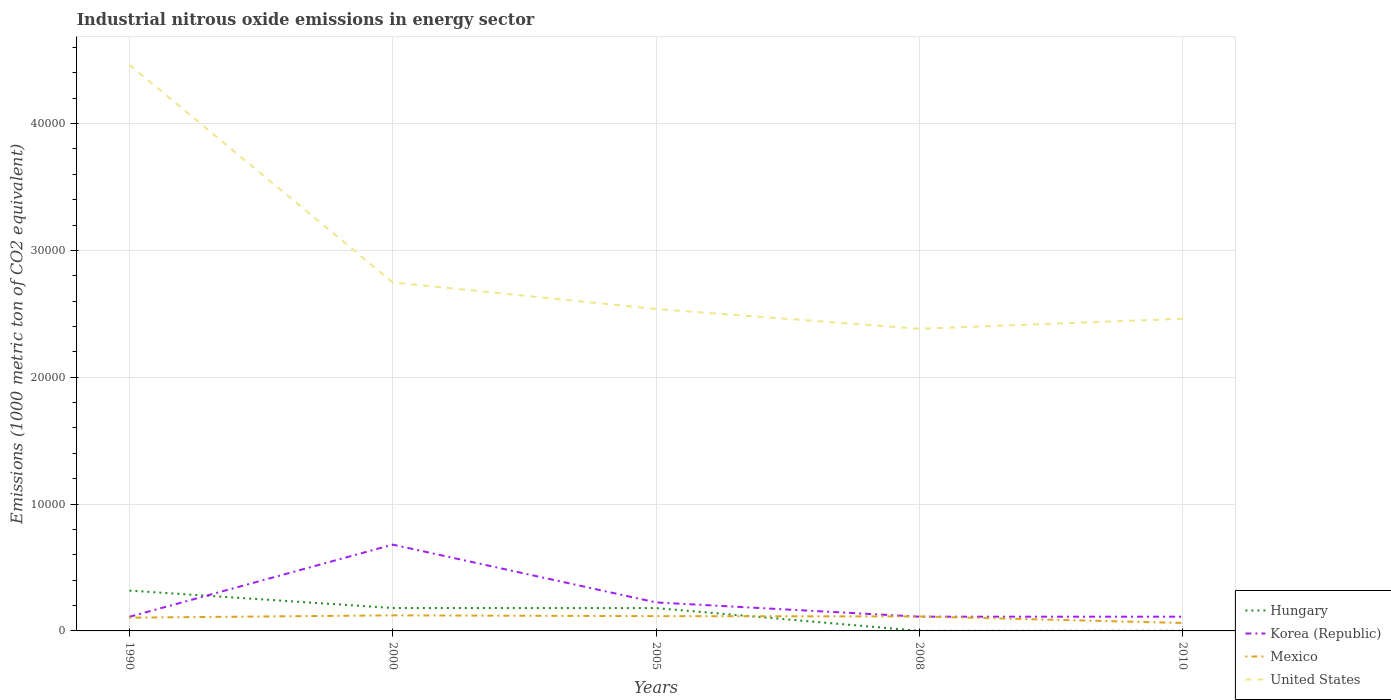Does the line corresponding to Korea (Republic) intersect with the line corresponding to Mexico?
Offer a terse response. Yes. Is the number of lines equal to the number of legend labels?
Make the answer very short. Yes. Across all years, what is the maximum amount of industrial nitrous oxide emitted in United States?
Offer a terse response. 2.38e+04. What is the total amount of industrial nitrous oxide emitted in Hungary in the graph?
Your answer should be very brief. 1376.6. What is the difference between the highest and the second highest amount of industrial nitrous oxide emitted in United States?
Give a very brief answer. 2.08e+04. What is the difference between the highest and the lowest amount of industrial nitrous oxide emitted in Mexico?
Provide a succinct answer. 4. Is the amount of industrial nitrous oxide emitted in Mexico strictly greater than the amount of industrial nitrous oxide emitted in Hungary over the years?
Offer a terse response. No. What is the difference between two consecutive major ticks on the Y-axis?
Keep it short and to the point. 10000. How many legend labels are there?
Offer a very short reply. 4. How are the legend labels stacked?
Offer a terse response. Vertical. What is the title of the graph?
Your response must be concise. Industrial nitrous oxide emissions in energy sector. What is the label or title of the X-axis?
Your answer should be compact. Years. What is the label or title of the Y-axis?
Give a very brief answer. Emissions (1000 metric ton of CO2 equivalent). What is the Emissions (1000 metric ton of CO2 equivalent) of Hungary in 1990?
Your answer should be compact. 3178.6. What is the Emissions (1000 metric ton of CO2 equivalent) in Korea (Republic) in 1990?
Give a very brief answer. 1112.3. What is the Emissions (1000 metric ton of CO2 equivalent) of Mexico in 1990?
Provide a short and direct response. 1046.3. What is the Emissions (1000 metric ton of CO2 equivalent) of United States in 1990?
Give a very brief answer. 4.46e+04. What is the Emissions (1000 metric ton of CO2 equivalent) of Hungary in 2000?
Your answer should be compact. 1805.4. What is the Emissions (1000 metric ton of CO2 equivalent) of Korea (Republic) in 2000?
Give a very brief answer. 6803. What is the Emissions (1000 metric ton of CO2 equivalent) in Mexico in 2000?
Make the answer very short. 1227.6. What is the Emissions (1000 metric ton of CO2 equivalent) of United States in 2000?
Give a very brief answer. 2.75e+04. What is the Emissions (1000 metric ton of CO2 equivalent) of Hungary in 2005?
Your answer should be compact. 1802. What is the Emissions (1000 metric ton of CO2 equivalent) of Korea (Republic) in 2005?
Your answer should be compact. 2247.5. What is the Emissions (1000 metric ton of CO2 equivalent) in Mexico in 2005?
Provide a succinct answer. 1164.8. What is the Emissions (1000 metric ton of CO2 equivalent) in United States in 2005?
Keep it short and to the point. 2.54e+04. What is the Emissions (1000 metric ton of CO2 equivalent) of Korea (Republic) in 2008?
Offer a very short reply. 1121.9. What is the Emissions (1000 metric ton of CO2 equivalent) of Mexico in 2008?
Give a very brief answer. 1141.1. What is the Emissions (1000 metric ton of CO2 equivalent) of United States in 2008?
Keep it short and to the point. 2.38e+04. What is the Emissions (1000 metric ton of CO2 equivalent) in Hungary in 2010?
Ensure brevity in your answer.  12.5. What is the Emissions (1000 metric ton of CO2 equivalent) of Korea (Republic) in 2010?
Make the answer very short. 1122.5. What is the Emissions (1000 metric ton of CO2 equivalent) of Mexico in 2010?
Keep it short and to the point. 626.8. What is the Emissions (1000 metric ton of CO2 equivalent) of United States in 2010?
Your answer should be compact. 2.46e+04. Across all years, what is the maximum Emissions (1000 metric ton of CO2 equivalent) in Hungary?
Make the answer very short. 3178.6. Across all years, what is the maximum Emissions (1000 metric ton of CO2 equivalent) of Korea (Republic)?
Provide a succinct answer. 6803. Across all years, what is the maximum Emissions (1000 metric ton of CO2 equivalent) in Mexico?
Your answer should be very brief. 1227.6. Across all years, what is the maximum Emissions (1000 metric ton of CO2 equivalent) of United States?
Your response must be concise. 4.46e+04. Across all years, what is the minimum Emissions (1000 metric ton of CO2 equivalent) of Hungary?
Your answer should be very brief. 6. Across all years, what is the minimum Emissions (1000 metric ton of CO2 equivalent) of Korea (Republic)?
Offer a very short reply. 1112.3. Across all years, what is the minimum Emissions (1000 metric ton of CO2 equivalent) in Mexico?
Ensure brevity in your answer.  626.8. Across all years, what is the minimum Emissions (1000 metric ton of CO2 equivalent) in United States?
Ensure brevity in your answer.  2.38e+04. What is the total Emissions (1000 metric ton of CO2 equivalent) of Hungary in the graph?
Give a very brief answer. 6804.5. What is the total Emissions (1000 metric ton of CO2 equivalent) of Korea (Republic) in the graph?
Provide a succinct answer. 1.24e+04. What is the total Emissions (1000 metric ton of CO2 equivalent) in Mexico in the graph?
Your response must be concise. 5206.6. What is the total Emissions (1000 metric ton of CO2 equivalent) of United States in the graph?
Make the answer very short. 1.46e+05. What is the difference between the Emissions (1000 metric ton of CO2 equivalent) of Hungary in 1990 and that in 2000?
Provide a short and direct response. 1373.2. What is the difference between the Emissions (1000 metric ton of CO2 equivalent) in Korea (Republic) in 1990 and that in 2000?
Provide a short and direct response. -5690.7. What is the difference between the Emissions (1000 metric ton of CO2 equivalent) in Mexico in 1990 and that in 2000?
Make the answer very short. -181.3. What is the difference between the Emissions (1000 metric ton of CO2 equivalent) in United States in 1990 and that in 2000?
Ensure brevity in your answer.  1.71e+04. What is the difference between the Emissions (1000 metric ton of CO2 equivalent) in Hungary in 1990 and that in 2005?
Provide a short and direct response. 1376.6. What is the difference between the Emissions (1000 metric ton of CO2 equivalent) of Korea (Republic) in 1990 and that in 2005?
Make the answer very short. -1135.2. What is the difference between the Emissions (1000 metric ton of CO2 equivalent) in Mexico in 1990 and that in 2005?
Ensure brevity in your answer.  -118.5. What is the difference between the Emissions (1000 metric ton of CO2 equivalent) of United States in 1990 and that in 2005?
Your answer should be very brief. 1.92e+04. What is the difference between the Emissions (1000 metric ton of CO2 equivalent) of Hungary in 1990 and that in 2008?
Keep it short and to the point. 3172.6. What is the difference between the Emissions (1000 metric ton of CO2 equivalent) of Korea (Republic) in 1990 and that in 2008?
Offer a very short reply. -9.6. What is the difference between the Emissions (1000 metric ton of CO2 equivalent) of Mexico in 1990 and that in 2008?
Keep it short and to the point. -94.8. What is the difference between the Emissions (1000 metric ton of CO2 equivalent) of United States in 1990 and that in 2008?
Your answer should be compact. 2.08e+04. What is the difference between the Emissions (1000 metric ton of CO2 equivalent) in Hungary in 1990 and that in 2010?
Your response must be concise. 3166.1. What is the difference between the Emissions (1000 metric ton of CO2 equivalent) in Mexico in 1990 and that in 2010?
Offer a very short reply. 419.5. What is the difference between the Emissions (1000 metric ton of CO2 equivalent) in United States in 1990 and that in 2010?
Provide a succinct answer. 2.00e+04. What is the difference between the Emissions (1000 metric ton of CO2 equivalent) in Hungary in 2000 and that in 2005?
Provide a succinct answer. 3.4. What is the difference between the Emissions (1000 metric ton of CO2 equivalent) in Korea (Republic) in 2000 and that in 2005?
Ensure brevity in your answer.  4555.5. What is the difference between the Emissions (1000 metric ton of CO2 equivalent) of Mexico in 2000 and that in 2005?
Ensure brevity in your answer.  62.8. What is the difference between the Emissions (1000 metric ton of CO2 equivalent) in United States in 2000 and that in 2005?
Your response must be concise. 2099.2. What is the difference between the Emissions (1000 metric ton of CO2 equivalent) of Hungary in 2000 and that in 2008?
Your answer should be compact. 1799.4. What is the difference between the Emissions (1000 metric ton of CO2 equivalent) of Korea (Republic) in 2000 and that in 2008?
Give a very brief answer. 5681.1. What is the difference between the Emissions (1000 metric ton of CO2 equivalent) in Mexico in 2000 and that in 2008?
Offer a terse response. 86.5. What is the difference between the Emissions (1000 metric ton of CO2 equivalent) of United States in 2000 and that in 2008?
Give a very brief answer. 3660.1. What is the difference between the Emissions (1000 metric ton of CO2 equivalent) of Hungary in 2000 and that in 2010?
Keep it short and to the point. 1792.9. What is the difference between the Emissions (1000 metric ton of CO2 equivalent) in Korea (Republic) in 2000 and that in 2010?
Your answer should be compact. 5680.5. What is the difference between the Emissions (1000 metric ton of CO2 equivalent) in Mexico in 2000 and that in 2010?
Keep it short and to the point. 600.8. What is the difference between the Emissions (1000 metric ton of CO2 equivalent) in United States in 2000 and that in 2010?
Your answer should be very brief. 2866.4. What is the difference between the Emissions (1000 metric ton of CO2 equivalent) in Hungary in 2005 and that in 2008?
Offer a terse response. 1796. What is the difference between the Emissions (1000 metric ton of CO2 equivalent) in Korea (Republic) in 2005 and that in 2008?
Your response must be concise. 1125.6. What is the difference between the Emissions (1000 metric ton of CO2 equivalent) in Mexico in 2005 and that in 2008?
Offer a very short reply. 23.7. What is the difference between the Emissions (1000 metric ton of CO2 equivalent) of United States in 2005 and that in 2008?
Offer a terse response. 1560.9. What is the difference between the Emissions (1000 metric ton of CO2 equivalent) in Hungary in 2005 and that in 2010?
Make the answer very short. 1789.5. What is the difference between the Emissions (1000 metric ton of CO2 equivalent) in Korea (Republic) in 2005 and that in 2010?
Your answer should be very brief. 1125. What is the difference between the Emissions (1000 metric ton of CO2 equivalent) in Mexico in 2005 and that in 2010?
Your answer should be compact. 538. What is the difference between the Emissions (1000 metric ton of CO2 equivalent) of United States in 2005 and that in 2010?
Ensure brevity in your answer.  767.2. What is the difference between the Emissions (1000 metric ton of CO2 equivalent) in Korea (Republic) in 2008 and that in 2010?
Your response must be concise. -0.6. What is the difference between the Emissions (1000 metric ton of CO2 equivalent) in Mexico in 2008 and that in 2010?
Keep it short and to the point. 514.3. What is the difference between the Emissions (1000 metric ton of CO2 equivalent) of United States in 2008 and that in 2010?
Your answer should be very brief. -793.7. What is the difference between the Emissions (1000 metric ton of CO2 equivalent) of Hungary in 1990 and the Emissions (1000 metric ton of CO2 equivalent) of Korea (Republic) in 2000?
Provide a short and direct response. -3624.4. What is the difference between the Emissions (1000 metric ton of CO2 equivalent) in Hungary in 1990 and the Emissions (1000 metric ton of CO2 equivalent) in Mexico in 2000?
Your answer should be very brief. 1951. What is the difference between the Emissions (1000 metric ton of CO2 equivalent) of Hungary in 1990 and the Emissions (1000 metric ton of CO2 equivalent) of United States in 2000?
Your response must be concise. -2.43e+04. What is the difference between the Emissions (1000 metric ton of CO2 equivalent) of Korea (Republic) in 1990 and the Emissions (1000 metric ton of CO2 equivalent) of Mexico in 2000?
Keep it short and to the point. -115.3. What is the difference between the Emissions (1000 metric ton of CO2 equivalent) of Korea (Republic) in 1990 and the Emissions (1000 metric ton of CO2 equivalent) of United States in 2000?
Provide a succinct answer. -2.64e+04. What is the difference between the Emissions (1000 metric ton of CO2 equivalent) in Mexico in 1990 and the Emissions (1000 metric ton of CO2 equivalent) in United States in 2000?
Make the answer very short. -2.64e+04. What is the difference between the Emissions (1000 metric ton of CO2 equivalent) in Hungary in 1990 and the Emissions (1000 metric ton of CO2 equivalent) in Korea (Republic) in 2005?
Give a very brief answer. 931.1. What is the difference between the Emissions (1000 metric ton of CO2 equivalent) of Hungary in 1990 and the Emissions (1000 metric ton of CO2 equivalent) of Mexico in 2005?
Provide a succinct answer. 2013.8. What is the difference between the Emissions (1000 metric ton of CO2 equivalent) in Hungary in 1990 and the Emissions (1000 metric ton of CO2 equivalent) in United States in 2005?
Your response must be concise. -2.22e+04. What is the difference between the Emissions (1000 metric ton of CO2 equivalent) in Korea (Republic) in 1990 and the Emissions (1000 metric ton of CO2 equivalent) in Mexico in 2005?
Offer a terse response. -52.5. What is the difference between the Emissions (1000 metric ton of CO2 equivalent) of Korea (Republic) in 1990 and the Emissions (1000 metric ton of CO2 equivalent) of United States in 2005?
Your response must be concise. -2.43e+04. What is the difference between the Emissions (1000 metric ton of CO2 equivalent) of Mexico in 1990 and the Emissions (1000 metric ton of CO2 equivalent) of United States in 2005?
Provide a succinct answer. -2.43e+04. What is the difference between the Emissions (1000 metric ton of CO2 equivalent) of Hungary in 1990 and the Emissions (1000 metric ton of CO2 equivalent) of Korea (Republic) in 2008?
Offer a very short reply. 2056.7. What is the difference between the Emissions (1000 metric ton of CO2 equivalent) in Hungary in 1990 and the Emissions (1000 metric ton of CO2 equivalent) in Mexico in 2008?
Offer a terse response. 2037.5. What is the difference between the Emissions (1000 metric ton of CO2 equivalent) in Hungary in 1990 and the Emissions (1000 metric ton of CO2 equivalent) in United States in 2008?
Offer a very short reply. -2.06e+04. What is the difference between the Emissions (1000 metric ton of CO2 equivalent) of Korea (Republic) in 1990 and the Emissions (1000 metric ton of CO2 equivalent) of Mexico in 2008?
Provide a succinct answer. -28.8. What is the difference between the Emissions (1000 metric ton of CO2 equivalent) of Korea (Republic) in 1990 and the Emissions (1000 metric ton of CO2 equivalent) of United States in 2008?
Ensure brevity in your answer.  -2.27e+04. What is the difference between the Emissions (1000 metric ton of CO2 equivalent) of Mexico in 1990 and the Emissions (1000 metric ton of CO2 equivalent) of United States in 2008?
Your response must be concise. -2.28e+04. What is the difference between the Emissions (1000 metric ton of CO2 equivalent) of Hungary in 1990 and the Emissions (1000 metric ton of CO2 equivalent) of Korea (Republic) in 2010?
Your answer should be very brief. 2056.1. What is the difference between the Emissions (1000 metric ton of CO2 equivalent) in Hungary in 1990 and the Emissions (1000 metric ton of CO2 equivalent) in Mexico in 2010?
Your response must be concise. 2551.8. What is the difference between the Emissions (1000 metric ton of CO2 equivalent) in Hungary in 1990 and the Emissions (1000 metric ton of CO2 equivalent) in United States in 2010?
Offer a very short reply. -2.14e+04. What is the difference between the Emissions (1000 metric ton of CO2 equivalent) of Korea (Republic) in 1990 and the Emissions (1000 metric ton of CO2 equivalent) of Mexico in 2010?
Your response must be concise. 485.5. What is the difference between the Emissions (1000 metric ton of CO2 equivalent) in Korea (Republic) in 1990 and the Emissions (1000 metric ton of CO2 equivalent) in United States in 2010?
Ensure brevity in your answer.  -2.35e+04. What is the difference between the Emissions (1000 metric ton of CO2 equivalent) in Mexico in 1990 and the Emissions (1000 metric ton of CO2 equivalent) in United States in 2010?
Provide a short and direct response. -2.36e+04. What is the difference between the Emissions (1000 metric ton of CO2 equivalent) in Hungary in 2000 and the Emissions (1000 metric ton of CO2 equivalent) in Korea (Republic) in 2005?
Your answer should be compact. -442.1. What is the difference between the Emissions (1000 metric ton of CO2 equivalent) in Hungary in 2000 and the Emissions (1000 metric ton of CO2 equivalent) in Mexico in 2005?
Make the answer very short. 640.6. What is the difference between the Emissions (1000 metric ton of CO2 equivalent) of Hungary in 2000 and the Emissions (1000 metric ton of CO2 equivalent) of United States in 2005?
Offer a terse response. -2.36e+04. What is the difference between the Emissions (1000 metric ton of CO2 equivalent) in Korea (Republic) in 2000 and the Emissions (1000 metric ton of CO2 equivalent) in Mexico in 2005?
Provide a short and direct response. 5638.2. What is the difference between the Emissions (1000 metric ton of CO2 equivalent) of Korea (Republic) in 2000 and the Emissions (1000 metric ton of CO2 equivalent) of United States in 2005?
Offer a terse response. -1.86e+04. What is the difference between the Emissions (1000 metric ton of CO2 equivalent) of Mexico in 2000 and the Emissions (1000 metric ton of CO2 equivalent) of United States in 2005?
Provide a succinct answer. -2.42e+04. What is the difference between the Emissions (1000 metric ton of CO2 equivalent) in Hungary in 2000 and the Emissions (1000 metric ton of CO2 equivalent) in Korea (Republic) in 2008?
Ensure brevity in your answer.  683.5. What is the difference between the Emissions (1000 metric ton of CO2 equivalent) of Hungary in 2000 and the Emissions (1000 metric ton of CO2 equivalent) of Mexico in 2008?
Provide a succinct answer. 664.3. What is the difference between the Emissions (1000 metric ton of CO2 equivalent) of Hungary in 2000 and the Emissions (1000 metric ton of CO2 equivalent) of United States in 2008?
Your answer should be compact. -2.20e+04. What is the difference between the Emissions (1000 metric ton of CO2 equivalent) of Korea (Republic) in 2000 and the Emissions (1000 metric ton of CO2 equivalent) of Mexico in 2008?
Offer a very short reply. 5661.9. What is the difference between the Emissions (1000 metric ton of CO2 equivalent) of Korea (Republic) in 2000 and the Emissions (1000 metric ton of CO2 equivalent) of United States in 2008?
Make the answer very short. -1.70e+04. What is the difference between the Emissions (1000 metric ton of CO2 equivalent) in Mexico in 2000 and the Emissions (1000 metric ton of CO2 equivalent) in United States in 2008?
Provide a short and direct response. -2.26e+04. What is the difference between the Emissions (1000 metric ton of CO2 equivalent) of Hungary in 2000 and the Emissions (1000 metric ton of CO2 equivalent) of Korea (Republic) in 2010?
Your response must be concise. 682.9. What is the difference between the Emissions (1000 metric ton of CO2 equivalent) in Hungary in 2000 and the Emissions (1000 metric ton of CO2 equivalent) in Mexico in 2010?
Offer a very short reply. 1178.6. What is the difference between the Emissions (1000 metric ton of CO2 equivalent) of Hungary in 2000 and the Emissions (1000 metric ton of CO2 equivalent) of United States in 2010?
Your answer should be very brief. -2.28e+04. What is the difference between the Emissions (1000 metric ton of CO2 equivalent) of Korea (Republic) in 2000 and the Emissions (1000 metric ton of CO2 equivalent) of Mexico in 2010?
Provide a short and direct response. 6176.2. What is the difference between the Emissions (1000 metric ton of CO2 equivalent) in Korea (Republic) in 2000 and the Emissions (1000 metric ton of CO2 equivalent) in United States in 2010?
Provide a short and direct response. -1.78e+04. What is the difference between the Emissions (1000 metric ton of CO2 equivalent) in Mexico in 2000 and the Emissions (1000 metric ton of CO2 equivalent) in United States in 2010?
Your answer should be very brief. -2.34e+04. What is the difference between the Emissions (1000 metric ton of CO2 equivalent) of Hungary in 2005 and the Emissions (1000 metric ton of CO2 equivalent) of Korea (Republic) in 2008?
Your answer should be compact. 680.1. What is the difference between the Emissions (1000 metric ton of CO2 equivalent) of Hungary in 2005 and the Emissions (1000 metric ton of CO2 equivalent) of Mexico in 2008?
Your response must be concise. 660.9. What is the difference between the Emissions (1000 metric ton of CO2 equivalent) of Hungary in 2005 and the Emissions (1000 metric ton of CO2 equivalent) of United States in 2008?
Make the answer very short. -2.20e+04. What is the difference between the Emissions (1000 metric ton of CO2 equivalent) in Korea (Republic) in 2005 and the Emissions (1000 metric ton of CO2 equivalent) in Mexico in 2008?
Keep it short and to the point. 1106.4. What is the difference between the Emissions (1000 metric ton of CO2 equivalent) of Korea (Republic) in 2005 and the Emissions (1000 metric ton of CO2 equivalent) of United States in 2008?
Your answer should be compact. -2.16e+04. What is the difference between the Emissions (1000 metric ton of CO2 equivalent) of Mexico in 2005 and the Emissions (1000 metric ton of CO2 equivalent) of United States in 2008?
Provide a succinct answer. -2.27e+04. What is the difference between the Emissions (1000 metric ton of CO2 equivalent) of Hungary in 2005 and the Emissions (1000 metric ton of CO2 equivalent) of Korea (Republic) in 2010?
Your answer should be compact. 679.5. What is the difference between the Emissions (1000 metric ton of CO2 equivalent) of Hungary in 2005 and the Emissions (1000 metric ton of CO2 equivalent) of Mexico in 2010?
Your answer should be very brief. 1175.2. What is the difference between the Emissions (1000 metric ton of CO2 equivalent) in Hungary in 2005 and the Emissions (1000 metric ton of CO2 equivalent) in United States in 2010?
Offer a very short reply. -2.28e+04. What is the difference between the Emissions (1000 metric ton of CO2 equivalent) in Korea (Republic) in 2005 and the Emissions (1000 metric ton of CO2 equivalent) in Mexico in 2010?
Your answer should be very brief. 1620.7. What is the difference between the Emissions (1000 metric ton of CO2 equivalent) of Korea (Republic) in 2005 and the Emissions (1000 metric ton of CO2 equivalent) of United States in 2010?
Give a very brief answer. -2.24e+04. What is the difference between the Emissions (1000 metric ton of CO2 equivalent) in Mexico in 2005 and the Emissions (1000 metric ton of CO2 equivalent) in United States in 2010?
Give a very brief answer. -2.34e+04. What is the difference between the Emissions (1000 metric ton of CO2 equivalent) in Hungary in 2008 and the Emissions (1000 metric ton of CO2 equivalent) in Korea (Republic) in 2010?
Provide a short and direct response. -1116.5. What is the difference between the Emissions (1000 metric ton of CO2 equivalent) in Hungary in 2008 and the Emissions (1000 metric ton of CO2 equivalent) in Mexico in 2010?
Offer a very short reply. -620.8. What is the difference between the Emissions (1000 metric ton of CO2 equivalent) of Hungary in 2008 and the Emissions (1000 metric ton of CO2 equivalent) of United States in 2010?
Provide a succinct answer. -2.46e+04. What is the difference between the Emissions (1000 metric ton of CO2 equivalent) in Korea (Republic) in 2008 and the Emissions (1000 metric ton of CO2 equivalent) in Mexico in 2010?
Provide a short and direct response. 495.1. What is the difference between the Emissions (1000 metric ton of CO2 equivalent) in Korea (Republic) in 2008 and the Emissions (1000 metric ton of CO2 equivalent) in United States in 2010?
Give a very brief answer. -2.35e+04. What is the difference between the Emissions (1000 metric ton of CO2 equivalent) of Mexico in 2008 and the Emissions (1000 metric ton of CO2 equivalent) of United States in 2010?
Ensure brevity in your answer.  -2.35e+04. What is the average Emissions (1000 metric ton of CO2 equivalent) of Hungary per year?
Your answer should be very brief. 1360.9. What is the average Emissions (1000 metric ton of CO2 equivalent) in Korea (Republic) per year?
Offer a terse response. 2481.44. What is the average Emissions (1000 metric ton of CO2 equivalent) of Mexico per year?
Offer a terse response. 1041.32. What is the average Emissions (1000 metric ton of CO2 equivalent) of United States per year?
Your answer should be compact. 2.92e+04. In the year 1990, what is the difference between the Emissions (1000 metric ton of CO2 equivalent) of Hungary and Emissions (1000 metric ton of CO2 equivalent) of Korea (Republic)?
Keep it short and to the point. 2066.3. In the year 1990, what is the difference between the Emissions (1000 metric ton of CO2 equivalent) in Hungary and Emissions (1000 metric ton of CO2 equivalent) in Mexico?
Keep it short and to the point. 2132.3. In the year 1990, what is the difference between the Emissions (1000 metric ton of CO2 equivalent) in Hungary and Emissions (1000 metric ton of CO2 equivalent) in United States?
Ensure brevity in your answer.  -4.14e+04. In the year 1990, what is the difference between the Emissions (1000 metric ton of CO2 equivalent) of Korea (Republic) and Emissions (1000 metric ton of CO2 equivalent) of Mexico?
Keep it short and to the point. 66. In the year 1990, what is the difference between the Emissions (1000 metric ton of CO2 equivalent) in Korea (Republic) and Emissions (1000 metric ton of CO2 equivalent) in United States?
Give a very brief answer. -4.35e+04. In the year 1990, what is the difference between the Emissions (1000 metric ton of CO2 equivalent) in Mexico and Emissions (1000 metric ton of CO2 equivalent) in United States?
Provide a succinct answer. -4.36e+04. In the year 2000, what is the difference between the Emissions (1000 metric ton of CO2 equivalent) of Hungary and Emissions (1000 metric ton of CO2 equivalent) of Korea (Republic)?
Make the answer very short. -4997.6. In the year 2000, what is the difference between the Emissions (1000 metric ton of CO2 equivalent) of Hungary and Emissions (1000 metric ton of CO2 equivalent) of Mexico?
Provide a short and direct response. 577.8. In the year 2000, what is the difference between the Emissions (1000 metric ton of CO2 equivalent) in Hungary and Emissions (1000 metric ton of CO2 equivalent) in United States?
Provide a short and direct response. -2.57e+04. In the year 2000, what is the difference between the Emissions (1000 metric ton of CO2 equivalent) of Korea (Republic) and Emissions (1000 metric ton of CO2 equivalent) of Mexico?
Provide a succinct answer. 5575.4. In the year 2000, what is the difference between the Emissions (1000 metric ton of CO2 equivalent) of Korea (Republic) and Emissions (1000 metric ton of CO2 equivalent) of United States?
Offer a very short reply. -2.07e+04. In the year 2000, what is the difference between the Emissions (1000 metric ton of CO2 equivalent) in Mexico and Emissions (1000 metric ton of CO2 equivalent) in United States?
Provide a short and direct response. -2.63e+04. In the year 2005, what is the difference between the Emissions (1000 metric ton of CO2 equivalent) in Hungary and Emissions (1000 metric ton of CO2 equivalent) in Korea (Republic)?
Give a very brief answer. -445.5. In the year 2005, what is the difference between the Emissions (1000 metric ton of CO2 equivalent) in Hungary and Emissions (1000 metric ton of CO2 equivalent) in Mexico?
Ensure brevity in your answer.  637.2. In the year 2005, what is the difference between the Emissions (1000 metric ton of CO2 equivalent) in Hungary and Emissions (1000 metric ton of CO2 equivalent) in United States?
Offer a terse response. -2.36e+04. In the year 2005, what is the difference between the Emissions (1000 metric ton of CO2 equivalent) in Korea (Republic) and Emissions (1000 metric ton of CO2 equivalent) in Mexico?
Keep it short and to the point. 1082.7. In the year 2005, what is the difference between the Emissions (1000 metric ton of CO2 equivalent) in Korea (Republic) and Emissions (1000 metric ton of CO2 equivalent) in United States?
Ensure brevity in your answer.  -2.31e+04. In the year 2005, what is the difference between the Emissions (1000 metric ton of CO2 equivalent) in Mexico and Emissions (1000 metric ton of CO2 equivalent) in United States?
Your answer should be very brief. -2.42e+04. In the year 2008, what is the difference between the Emissions (1000 metric ton of CO2 equivalent) in Hungary and Emissions (1000 metric ton of CO2 equivalent) in Korea (Republic)?
Your answer should be very brief. -1115.9. In the year 2008, what is the difference between the Emissions (1000 metric ton of CO2 equivalent) in Hungary and Emissions (1000 metric ton of CO2 equivalent) in Mexico?
Your response must be concise. -1135.1. In the year 2008, what is the difference between the Emissions (1000 metric ton of CO2 equivalent) in Hungary and Emissions (1000 metric ton of CO2 equivalent) in United States?
Make the answer very short. -2.38e+04. In the year 2008, what is the difference between the Emissions (1000 metric ton of CO2 equivalent) in Korea (Republic) and Emissions (1000 metric ton of CO2 equivalent) in Mexico?
Make the answer very short. -19.2. In the year 2008, what is the difference between the Emissions (1000 metric ton of CO2 equivalent) of Korea (Republic) and Emissions (1000 metric ton of CO2 equivalent) of United States?
Offer a very short reply. -2.27e+04. In the year 2008, what is the difference between the Emissions (1000 metric ton of CO2 equivalent) of Mexico and Emissions (1000 metric ton of CO2 equivalent) of United States?
Provide a succinct answer. -2.27e+04. In the year 2010, what is the difference between the Emissions (1000 metric ton of CO2 equivalent) of Hungary and Emissions (1000 metric ton of CO2 equivalent) of Korea (Republic)?
Ensure brevity in your answer.  -1110. In the year 2010, what is the difference between the Emissions (1000 metric ton of CO2 equivalent) in Hungary and Emissions (1000 metric ton of CO2 equivalent) in Mexico?
Offer a very short reply. -614.3. In the year 2010, what is the difference between the Emissions (1000 metric ton of CO2 equivalent) of Hungary and Emissions (1000 metric ton of CO2 equivalent) of United States?
Ensure brevity in your answer.  -2.46e+04. In the year 2010, what is the difference between the Emissions (1000 metric ton of CO2 equivalent) of Korea (Republic) and Emissions (1000 metric ton of CO2 equivalent) of Mexico?
Your answer should be very brief. 495.7. In the year 2010, what is the difference between the Emissions (1000 metric ton of CO2 equivalent) of Korea (Republic) and Emissions (1000 metric ton of CO2 equivalent) of United States?
Offer a terse response. -2.35e+04. In the year 2010, what is the difference between the Emissions (1000 metric ton of CO2 equivalent) in Mexico and Emissions (1000 metric ton of CO2 equivalent) in United States?
Your response must be concise. -2.40e+04. What is the ratio of the Emissions (1000 metric ton of CO2 equivalent) of Hungary in 1990 to that in 2000?
Provide a short and direct response. 1.76. What is the ratio of the Emissions (1000 metric ton of CO2 equivalent) in Korea (Republic) in 1990 to that in 2000?
Keep it short and to the point. 0.16. What is the ratio of the Emissions (1000 metric ton of CO2 equivalent) in Mexico in 1990 to that in 2000?
Provide a succinct answer. 0.85. What is the ratio of the Emissions (1000 metric ton of CO2 equivalent) of United States in 1990 to that in 2000?
Keep it short and to the point. 1.62. What is the ratio of the Emissions (1000 metric ton of CO2 equivalent) of Hungary in 1990 to that in 2005?
Ensure brevity in your answer.  1.76. What is the ratio of the Emissions (1000 metric ton of CO2 equivalent) in Korea (Republic) in 1990 to that in 2005?
Your answer should be very brief. 0.49. What is the ratio of the Emissions (1000 metric ton of CO2 equivalent) in Mexico in 1990 to that in 2005?
Your answer should be compact. 0.9. What is the ratio of the Emissions (1000 metric ton of CO2 equivalent) in United States in 1990 to that in 2005?
Provide a short and direct response. 1.76. What is the ratio of the Emissions (1000 metric ton of CO2 equivalent) in Hungary in 1990 to that in 2008?
Provide a short and direct response. 529.77. What is the ratio of the Emissions (1000 metric ton of CO2 equivalent) in Korea (Republic) in 1990 to that in 2008?
Ensure brevity in your answer.  0.99. What is the ratio of the Emissions (1000 metric ton of CO2 equivalent) of Mexico in 1990 to that in 2008?
Offer a terse response. 0.92. What is the ratio of the Emissions (1000 metric ton of CO2 equivalent) in United States in 1990 to that in 2008?
Offer a very short reply. 1.87. What is the ratio of the Emissions (1000 metric ton of CO2 equivalent) of Hungary in 1990 to that in 2010?
Your answer should be very brief. 254.29. What is the ratio of the Emissions (1000 metric ton of CO2 equivalent) of Korea (Republic) in 1990 to that in 2010?
Your answer should be compact. 0.99. What is the ratio of the Emissions (1000 metric ton of CO2 equivalent) in Mexico in 1990 to that in 2010?
Offer a terse response. 1.67. What is the ratio of the Emissions (1000 metric ton of CO2 equivalent) of United States in 1990 to that in 2010?
Give a very brief answer. 1.81. What is the ratio of the Emissions (1000 metric ton of CO2 equivalent) of Korea (Republic) in 2000 to that in 2005?
Ensure brevity in your answer.  3.03. What is the ratio of the Emissions (1000 metric ton of CO2 equivalent) in Mexico in 2000 to that in 2005?
Make the answer very short. 1.05. What is the ratio of the Emissions (1000 metric ton of CO2 equivalent) of United States in 2000 to that in 2005?
Your response must be concise. 1.08. What is the ratio of the Emissions (1000 metric ton of CO2 equivalent) in Hungary in 2000 to that in 2008?
Offer a terse response. 300.9. What is the ratio of the Emissions (1000 metric ton of CO2 equivalent) of Korea (Republic) in 2000 to that in 2008?
Provide a succinct answer. 6.06. What is the ratio of the Emissions (1000 metric ton of CO2 equivalent) of Mexico in 2000 to that in 2008?
Keep it short and to the point. 1.08. What is the ratio of the Emissions (1000 metric ton of CO2 equivalent) in United States in 2000 to that in 2008?
Offer a very short reply. 1.15. What is the ratio of the Emissions (1000 metric ton of CO2 equivalent) in Hungary in 2000 to that in 2010?
Offer a very short reply. 144.43. What is the ratio of the Emissions (1000 metric ton of CO2 equivalent) in Korea (Republic) in 2000 to that in 2010?
Provide a succinct answer. 6.06. What is the ratio of the Emissions (1000 metric ton of CO2 equivalent) of Mexico in 2000 to that in 2010?
Keep it short and to the point. 1.96. What is the ratio of the Emissions (1000 metric ton of CO2 equivalent) in United States in 2000 to that in 2010?
Provide a short and direct response. 1.12. What is the ratio of the Emissions (1000 metric ton of CO2 equivalent) of Hungary in 2005 to that in 2008?
Give a very brief answer. 300.33. What is the ratio of the Emissions (1000 metric ton of CO2 equivalent) of Korea (Republic) in 2005 to that in 2008?
Your answer should be very brief. 2. What is the ratio of the Emissions (1000 metric ton of CO2 equivalent) of Mexico in 2005 to that in 2008?
Provide a succinct answer. 1.02. What is the ratio of the Emissions (1000 metric ton of CO2 equivalent) of United States in 2005 to that in 2008?
Keep it short and to the point. 1.07. What is the ratio of the Emissions (1000 metric ton of CO2 equivalent) in Hungary in 2005 to that in 2010?
Provide a short and direct response. 144.16. What is the ratio of the Emissions (1000 metric ton of CO2 equivalent) in Korea (Republic) in 2005 to that in 2010?
Make the answer very short. 2. What is the ratio of the Emissions (1000 metric ton of CO2 equivalent) of Mexico in 2005 to that in 2010?
Make the answer very short. 1.86. What is the ratio of the Emissions (1000 metric ton of CO2 equivalent) of United States in 2005 to that in 2010?
Offer a very short reply. 1.03. What is the ratio of the Emissions (1000 metric ton of CO2 equivalent) in Hungary in 2008 to that in 2010?
Your response must be concise. 0.48. What is the ratio of the Emissions (1000 metric ton of CO2 equivalent) of Mexico in 2008 to that in 2010?
Provide a short and direct response. 1.82. What is the ratio of the Emissions (1000 metric ton of CO2 equivalent) in United States in 2008 to that in 2010?
Your answer should be compact. 0.97. What is the difference between the highest and the second highest Emissions (1000 metric ton of CO2 equivalent) of Hungary?
Your response must be concise. 1373.2. What is the difference between the highest and the second highest Emissions (1000 metric ton of CO2 equivalent) of Korea (Republic)?
Your answer should be very brief. 4555.5. What is the difference between the highest and the second highest Emissions (1000 metric ton of CO2 equivalent) in Mexico?
Your answer should be very brief. 62.8. What is the difference between the highest and the second highest Emissions (1000 metric ton of CO2 equivalent) in United States?
Give a very brief answer. 1.71e+04. What is the difference between the highest and the lowest Emissions (1000 metric ton of CO2 equivalent) in Hungary?
Your answer should be very brief. 3172.6. What is the difference between the highest and the lowest Emissions (1000 metric ton of CO2 equivalent) in Korea (Republic)?
Give a very brief answer. 5690.7. What is the difference between the highest and the lowest Emissions (1000 metric ton of CO2 equivalent) of Mexico?
Your answer should be very brief. 600.8. What is the difference between the highest and the lowest Emissions (1000 metric ton of CO2 equivalent) in United States?
Provide a short and direct response. 2.08e+04. 